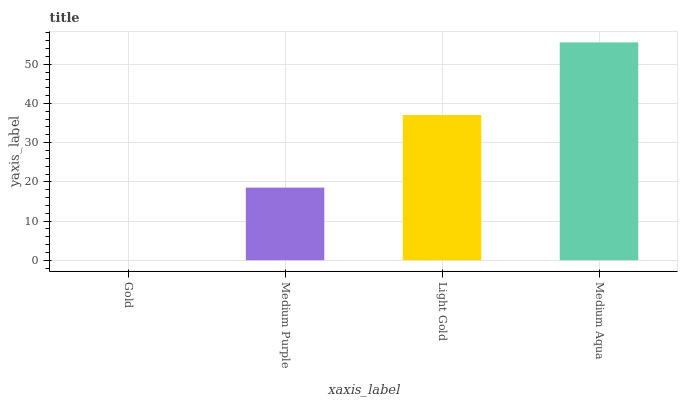Is Gold the minimum?
Answer yes or no. Yes. Is Medium Aqua the maximum?
Answer yes or no. Yes. Is Medium Purple the minimum?
Answer yes or no. No. Is Medium Purple the maximum?
Answer yes or no. No. Is Medium Purple greater than Gold?
Answer yes or no. Yes. Is Gold less than Medium Purple?
Answer yes or no. Yes. Is Gold greater than Medium Purple?
Answer yes or no. No. Is Medium Purple less than Gold?
Answer yes or no. No. Is Light Gold the high median?
Answer yes or no. Yes. Is Medium Purple the low median?
Answer yes or no. Yes. Is Medium Purple the high median?
Answer yes or no. No. Is Gold the low median?
Answer yes or no. No. 